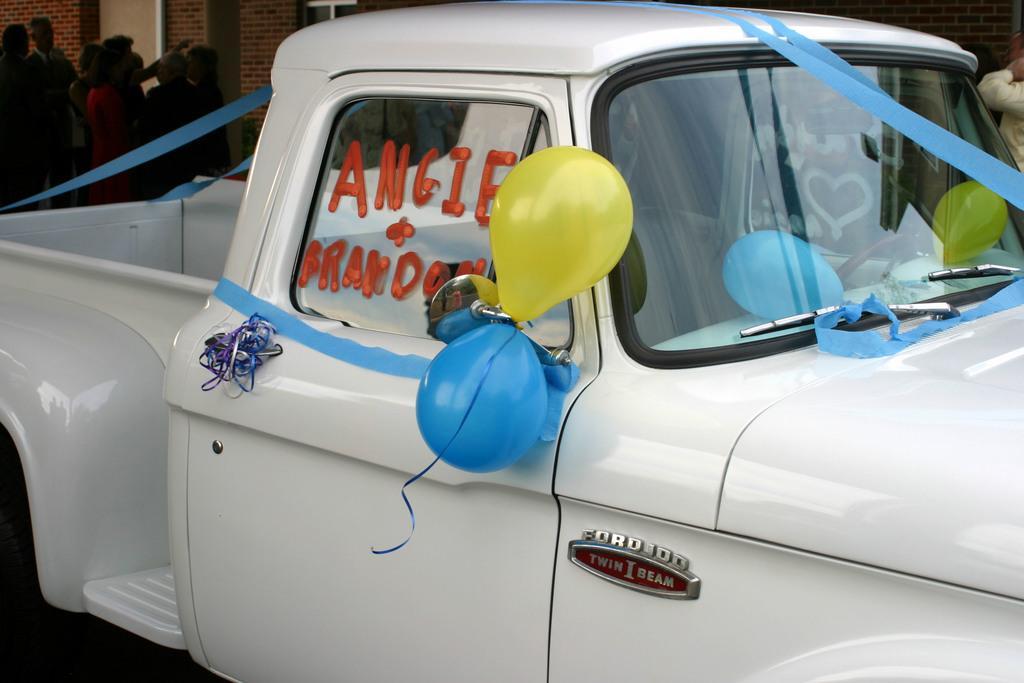How would you summarize this image in a sentence or two? In this image there is a vehicle for that vehicle there are balloons and ribbons, in the background there are people standing and there is a wall. 